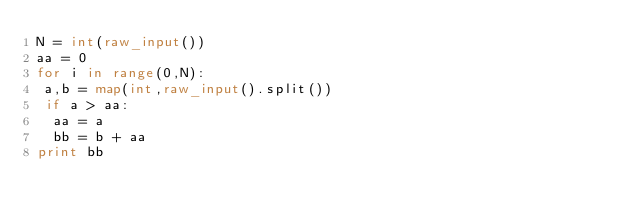<code> <loc_0><loc_0><loc_500><loc_500><_Python_>N = int(raw_input())
aa = 0
for i in range(0,N):
 a,b = map(int,raw_input().split())
 if a > aa:
  aa = a
  bb = b + aa
print bb</code> 